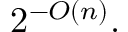Convert formula to latex. <formula><loc_0><loc_0><loc_500><loc_500>2 ^ { - O ( n ) } .</formula> 